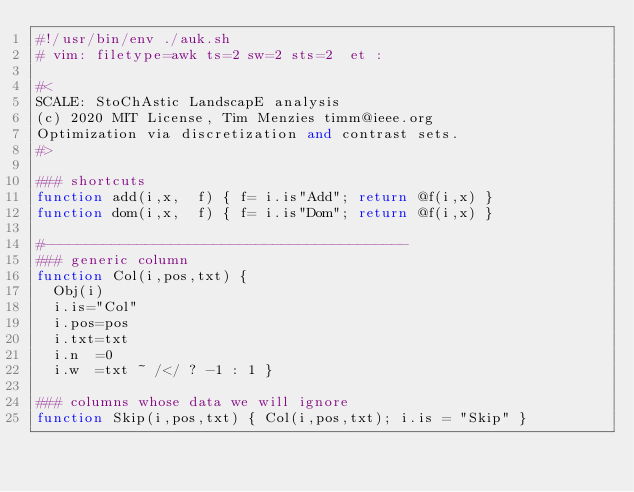<code> <loc_0><loc_0><loc_500><loc_500><_Awk_>#!/usr/bin/env ./auk.sh
# vim: filetype=awk ts=2 sw=2 sts=2  et :

#<
SCALE: StoChAstic LandscapE analysis
(c) 2020 MIT License, Tim Menzies timm@ieee.org
Optimization via discretization and contrast sets.
#>

### shortcuts
function add(i,x,  f) { f= i.is"Add"; return @f(i,x) }
function dom(i,x,  f) { f= i.is"Dom"; return @f(i,x) }

#-------------------------------------------
### generic column
function Col(i,pos,txt) {
  Obj(i)
  i.is="Col"
  i.pos=pos
  i.txt=txt
  i.n  =0
  i.w  =txt ~ /</ ? -1 : 1 }

### columns whose data we will ignore
function Skip(i,pos,txt) { Col(i,pos,txt); i.is = "Skip" }</code> 